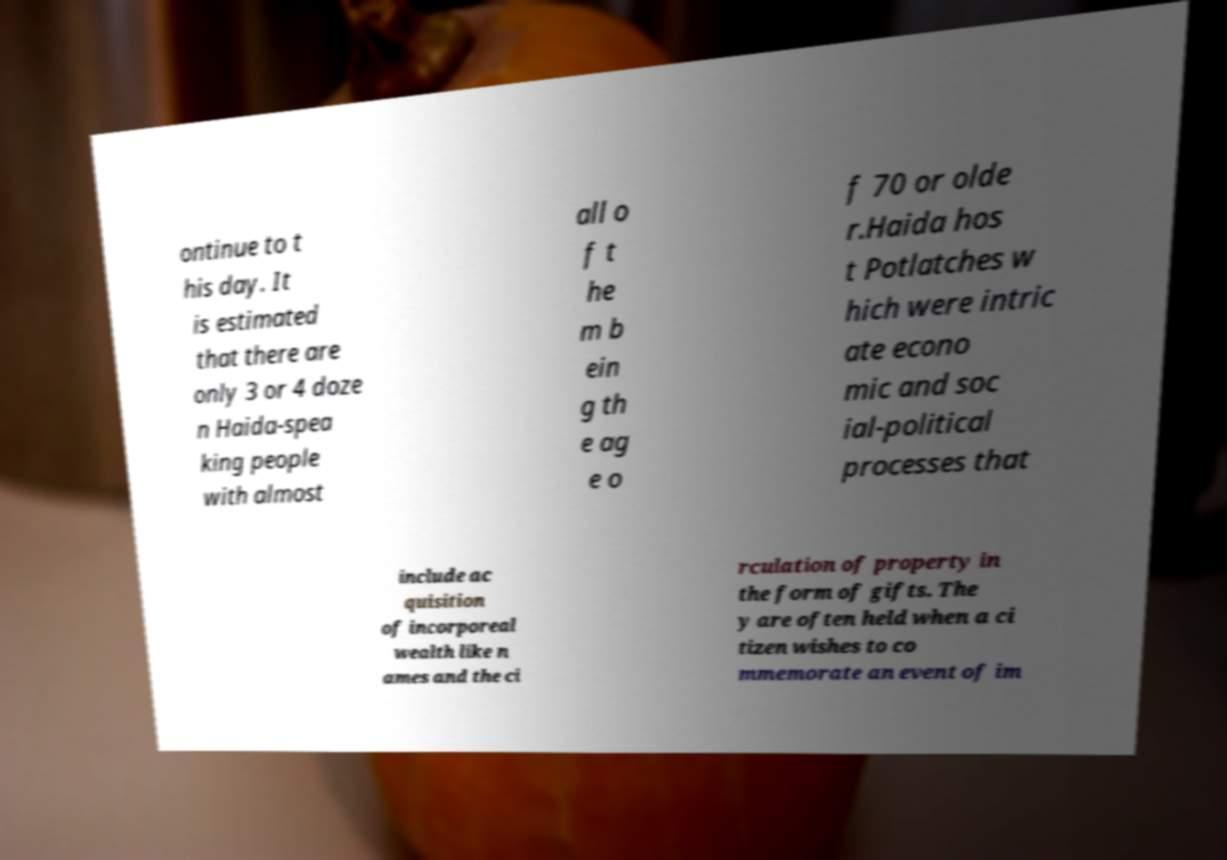What messages or text are displayed in this image? I need them in a readable, typed format. ontinue to t his day. It is estimated that there are only 3 or 4 doze n Haida-spea king people with almost all o f t he m b ein g th e ag e o f 70 or olde r.Haida hos t Potlatches w hich were intric ate econo mic and soc ial-political processes that include ac quisition of incorporeal wealth like n ames and the ci rculation of property in the form of gifts. The y are often held when a ci tizen wishes to co mmemorate an event of im 